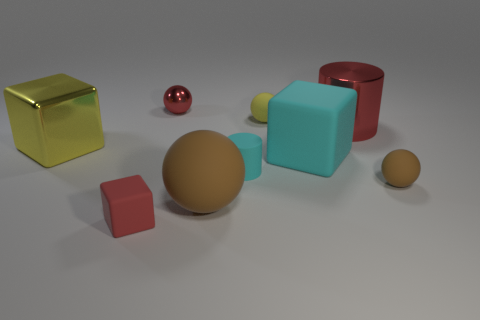Is the large metallic cylinder the same color as the small cube?
Offer a terse response. Yes. How many things are either cyan matte cylinders or red metal objects that are left of the large brown rubber object?
Keep it short and to the point. 2. There is a cube in front of the small cyan rubber cylinder; what is its size?
Provide a short and direct response. Small. The tiny matte object that is the same color as the big metallic cylinder is what shape?
Ensure brevity in your answer.  Cube. Does the tiny red block have the same material as the yellow thing on the right side of the red sphere?
Keep it short and to the point. Yes. What number of small red metal objects are behind the large metal cylinder on the right side of the large rubber object that is behind the tiny brown thing?
Give a very brief answer. 1. What number of red things are large matte objects or things?
Your response must be concise. 3. The tiny object to the left of the tiny red shiny sphere has what shape?
Keep it short and to the point. Cube. What color is the matte ball that is the same size as the red shiny cylinder?
Ensure brevity in your answer.  Brown. There is a tiny yellow rubber object; does it have the same shape as the small red object that is behind the big yellow metal object?
Keep it short and to the point. Yes. 